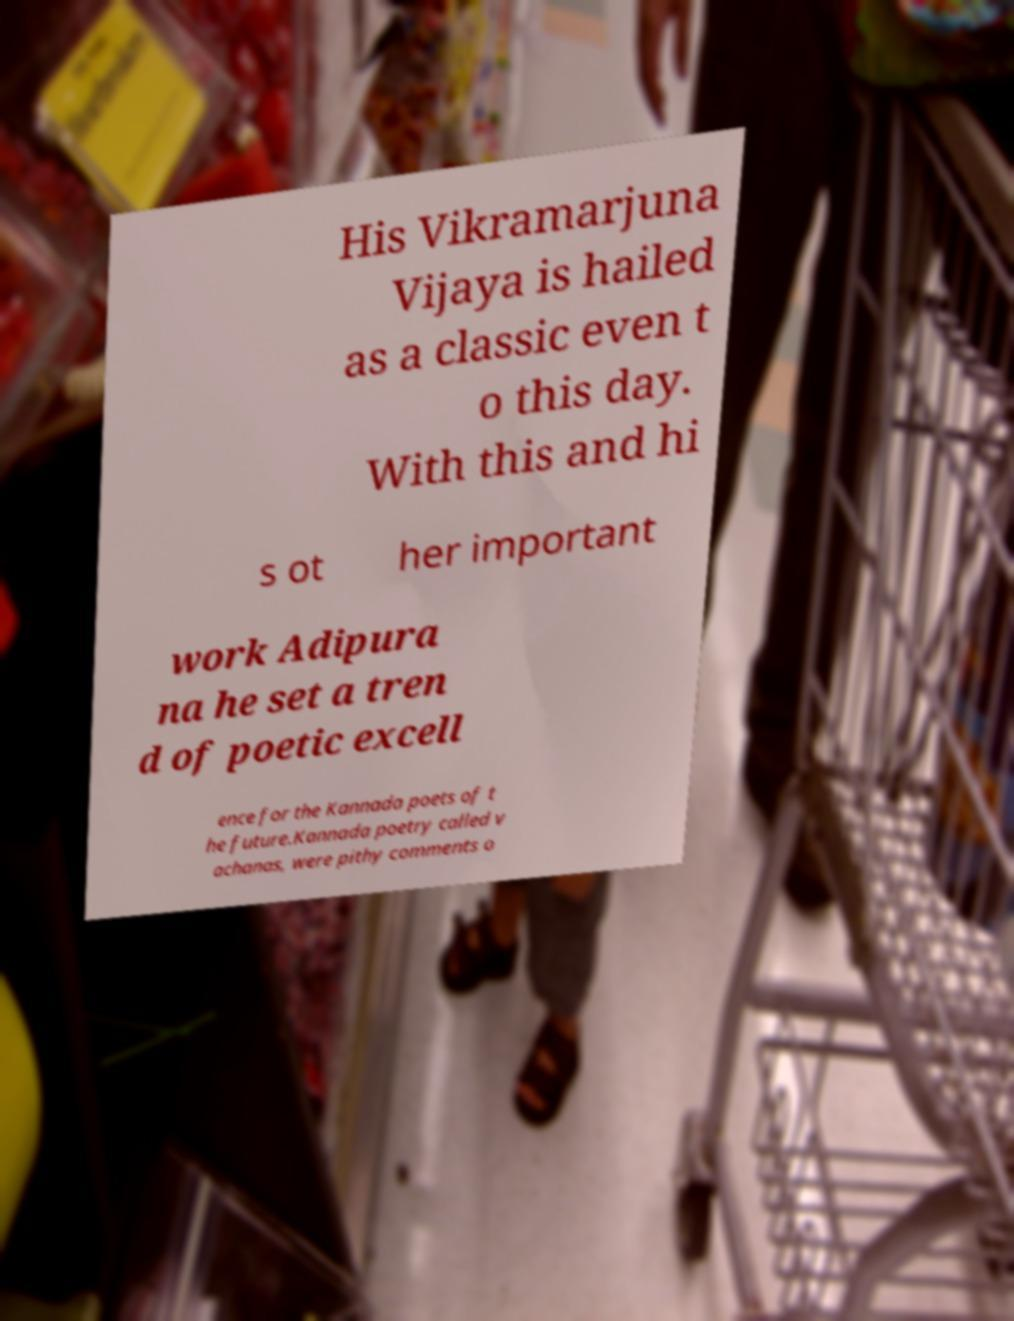Can you accurately transcribe the text from the provided image for me? His Vikramarjuna Vijaya is hailed as a classic even t o this day. With this and hi s ot her important work Adipura na he set a tren d of poetic excell ence for the Kannada poets of t he future.Kannada poetry called v achanas, were pithy comments o 